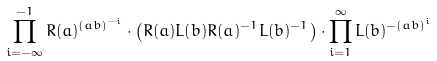<formula> <loc_0><loc_0><loc_500><loc_500>\prod _ { i = - \infty } ^ { - 1 } R ( a ) ^ { ( a b ) ^ { - i } } \cdot \left ( R ( a ) L ( b ) R ( a ) ^ { - 1 } L ( b ) ^ { - 1 } \right ) \cdot \prod _ { i = 1 } ^ { \infty } L ( b ) ^ { - ( a b ) ^ { i } }</formula> 